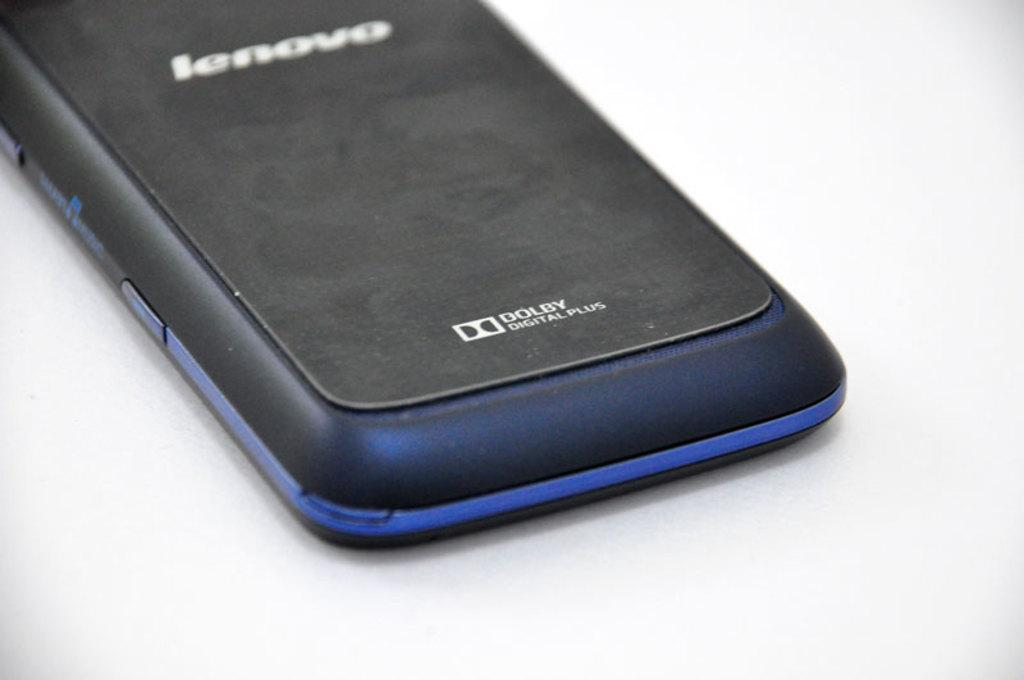<image>
Share a concise interpretation of the image provided. The back side of a blue and black Lenovo cell phone 